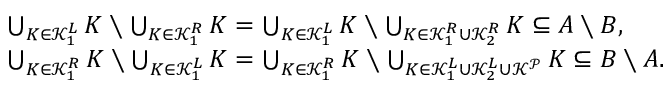Convert formula to latex. <formula><loc_0><loc_0><loc_500><loc_500>\begin{array} { r l } & { \bigcup _ { K \in \mathcal { K } _ { 1 } ^ { L } } K \ \bigcup _ { K \in \mathcal { K } _ { 1 } ^ { R } } K = \bigcup _ { K \in \mathcal { K } _ { 1 } ^ { L } } K \ \bigcup _ { K \in \mathcal { K } _ { 1 } ^ { R } \cup \mathcal { K } _ { 2 } ^ { R } } K \subseteq A \ B , } \\ & { \bigcup _ { K \in \mathcal { K } _ { 1 } ^ { R } } K \ \bigcup _ { K \in \mathcal { K } _ { 1 } ^ { L } } K = \bigcup _ { K \in \mathcal { K } _ { 1 } ^ { R } } K \ \bigcup _ { K \in \mathcal { K } _ { 1 } ^ { L } \cup \mathcal { K } _ { 2 } ^ { L } \cup \mathcal { K } ^ { \mathcal { P } } } K \subseteq B \ A . } \end{array}</formula> 